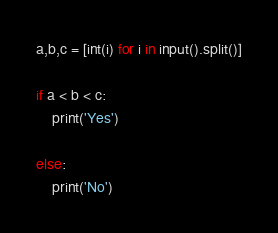<code> <loc_0><loc_0><loc_500><loc_500><_Python_>a,b,c = [int(i) for i in input().split()]

if a < b < c:
    print('Yes')

else:
    print('No')</code> 